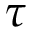Convert formula to latex. <formula><loc_0><loc_0><loc_500><loc_500>\tau</formula> 